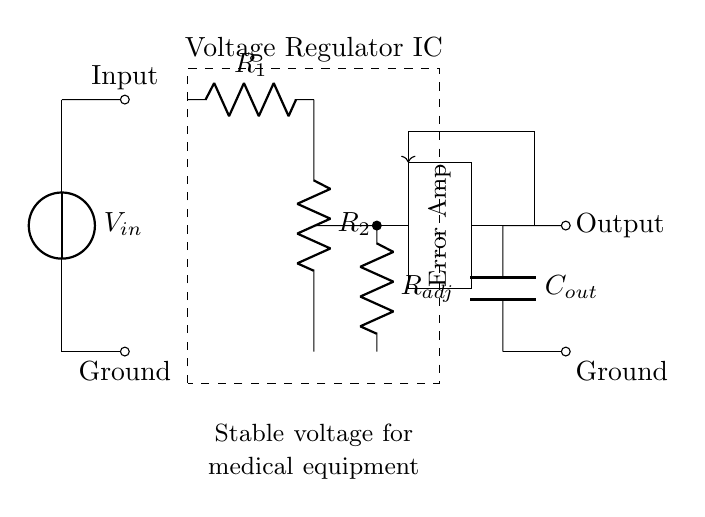What is the type of the main component in the circuit? The main component is labeled as "Voltage Regulator IC," which indicates that it is primarily responsible for regulating voltage levels.
Answer: Voltage Regulator IC What is the function of the resistors R1 and R2? R1 and R2 form a voltage divider, which is essential for setting the output voltage of the regulator by determining the feedback to the internal regulation mechanism.
Answer: Voltage divider What is the purpose of the capacitor labeled C_out? C_out is used to smooth out the output voltage, filtering any high-frequency noise and stabilizing the voltage delivered to the load connected at the output.
Answer: Smoothing How does the error amplifier influence the regulator's performance? The error amplifier compares the output voltage to a reference voltage and adjusts the regulation to minimize the difference, ensuring the output remains stable under varying load conditions.
Answer: Stability What is the output of the voltage regulator circuit? The output is defined visually as connected to the output node labeled "Output," representing the stable voltage supplied for medical equipment.
Answer: Stable voltage How is feedback provided in this circuit? Feedback is provided by the connection from the output to the error amplifier, allowing the regulator to adjust its output based on the feedback from the current output voltage.
Answer: Feedback loop 